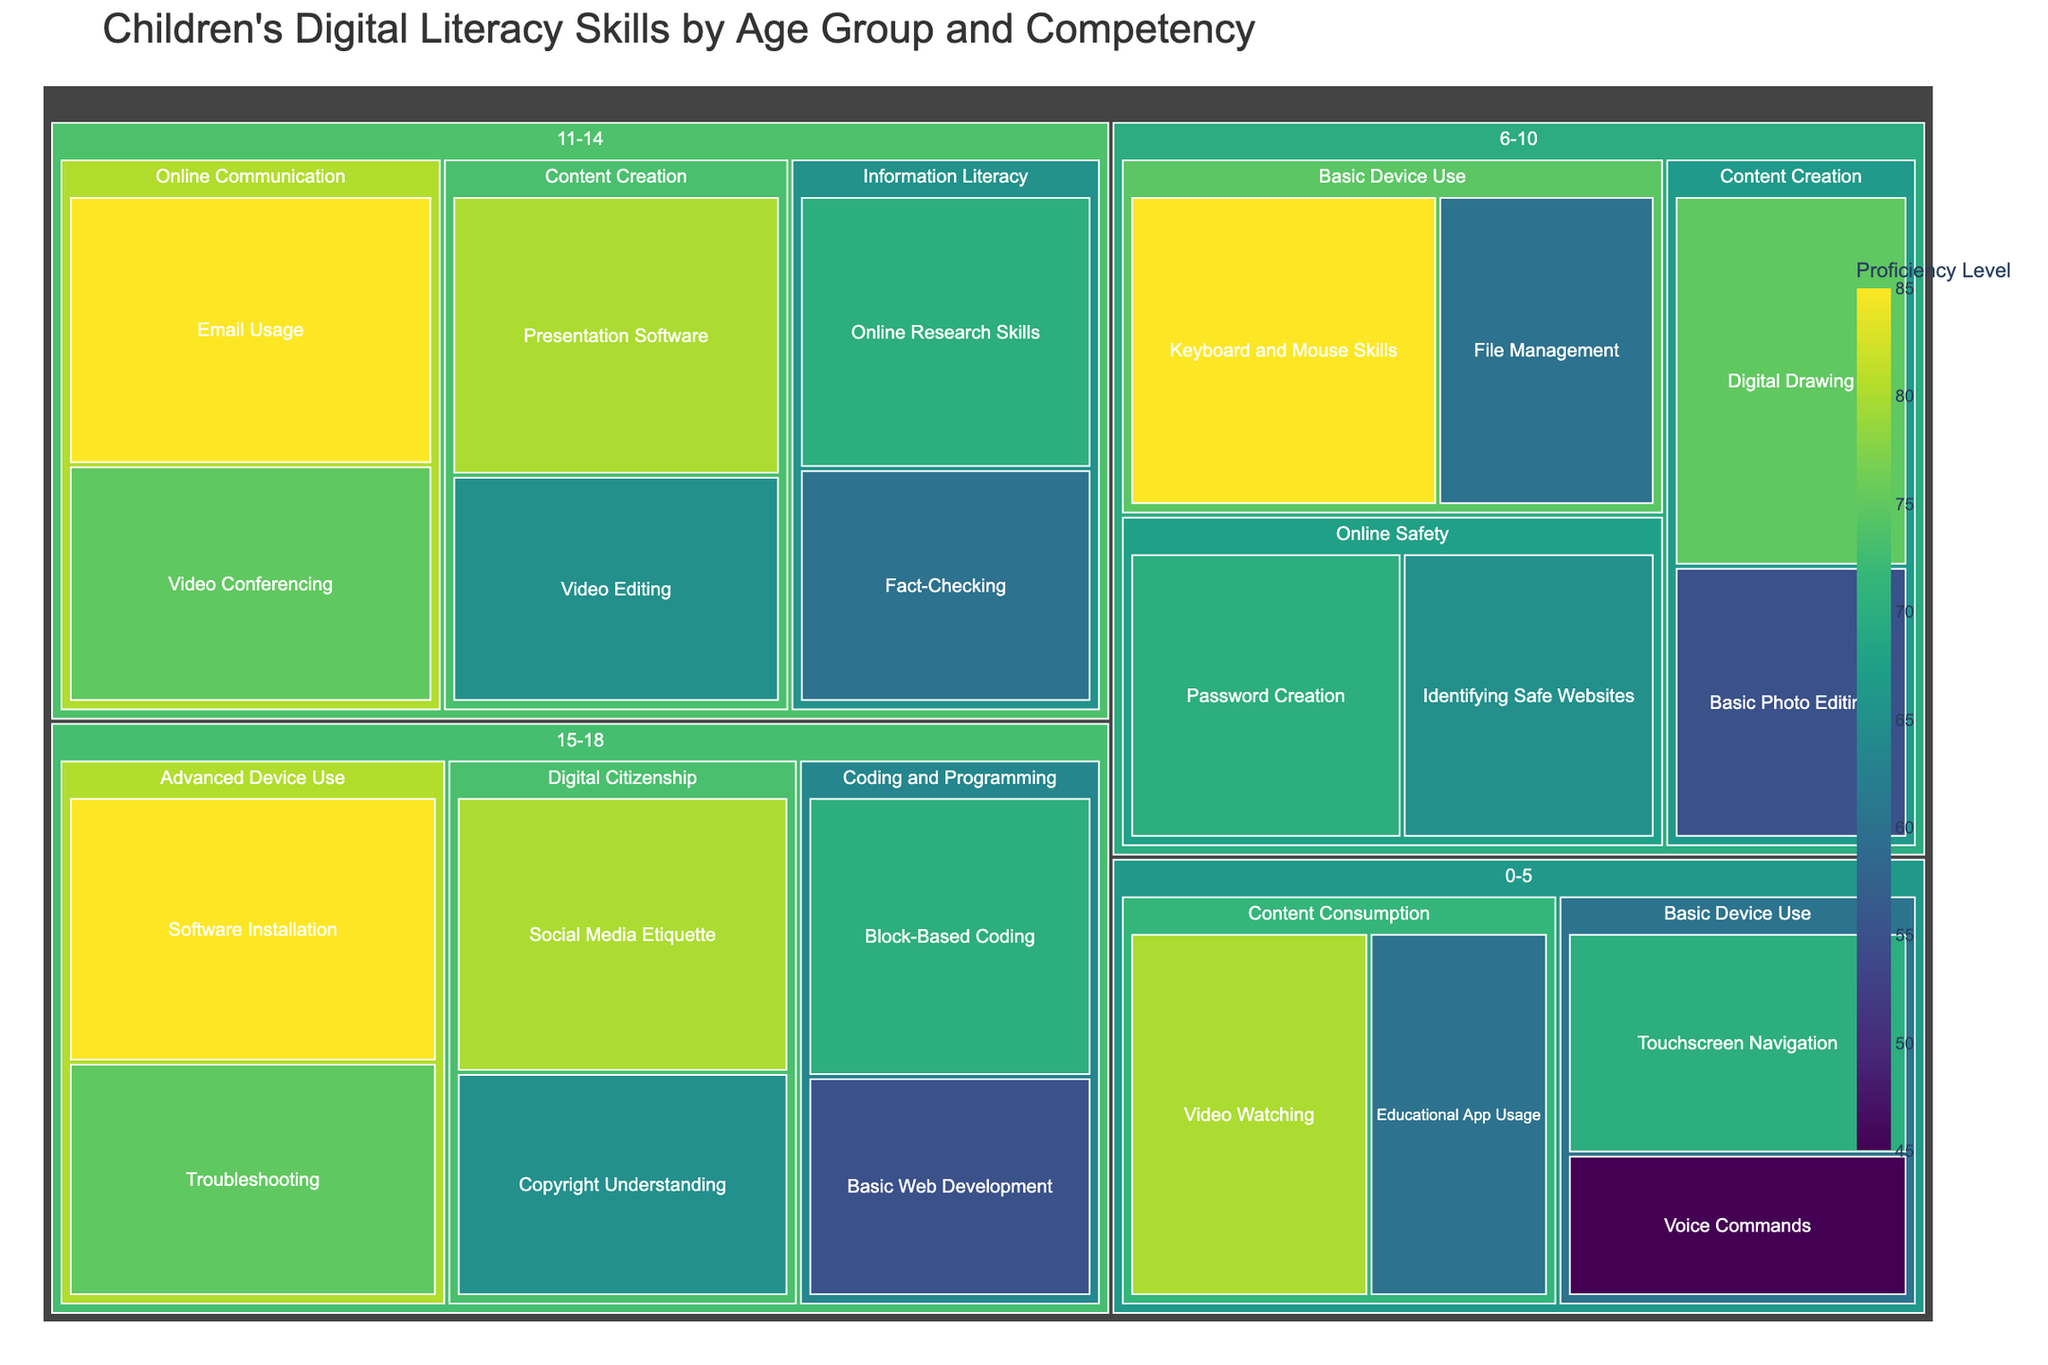What's the most proficient digital literacy skill for children aged 0-5? By looking at the treemap section for age group 0-5, the largest tile with the highest proficiency level indicates the most proficient skill. The "Video Watching" under the "Content Consumption" category has the largest area and highest proficiency.
Answer: Video Watching Which age group shows the highest proficiency in "Keyboard and Mouse Skills"? By locating the "Keyboard and Mouse Skills" competence, we see it is categorized under age group 6-10. The proficiency level at 85 is displayed, indicating high proficiency.
Answer: 6-10 Which specific competency in the "Content Creation" category has the lowest proficiency level for age group 6-10? Navigate to the "Content Creation" category under age group 6-10, then compare the proficiency levels of "Digital Drawing" and "Basic Photo Editing". "Basic Photo Editing" shows a proficiency level of 55, which is lower.
Answer: Basic Photo Editing For children aged 15-18, which category has the highest combined proficiency levels, and what is the value? For age group 15-18, sum the proficiency levels of competencies for each skill category. The categories are "Coding and Programming" (70 and 55), "Digital Citizenship" (80 and 65), and "Advanced Device Use" (75 and 85). The sums are 125, 145, and 160, respectively. "Advanced Device Use" has the highest combined proficiency.
Answer: Advanced Device Use, 160 How does the proficiency level in "Online Research Skills" for ages 11-14 compare to "Touchscreen Navigation" for ages 0-5? Locate both specific competencies. "Online Research Skills" under 11-14 has a proficiency level of 70, and "Touchscreen Navigation" under 0-5 also has 70. Thus, they are equal.
Answer: Equal Which skill category for ages 15-18 has the highest individual proficiency level, and what is this level? Look within each skill category for ages 15-18. Compare the proficiency levels: "Block-Based Coding" (70), "Basic Web Development" (55), "Social Media Etiquette" (80), "Copyright Understanding" (65), "Troubleshooting" (75), "Software Installation" (85). "Software Installation" has the highest level at 85.
Answer: Advanced Device Use, 85 What is the proficiency difference between "Email Usage" and "Video Conferencing" for ages 11-14? Find "Email Usage" and "Video Conferencing" under the 11-14 age group. The proficiency levels are 85 and 75, respectively. The difference is 85 - 75.
Answer: 10 Compare the overall proficiency in "Content Consumption" between age groups 0-5 and 6-10. Which group has a higher combined proficiency, and by how much? For age group 0-5, sum the proficiency levels for "Educational App Usage" (60) and "Video Watching" (80). For age group 6-10, there is no "Content Consumption" category. The sum for 0-5 is 140, and for 6-10 is 0. The difference is 140 - 0.
Answer: Age group 0-5, by 140 